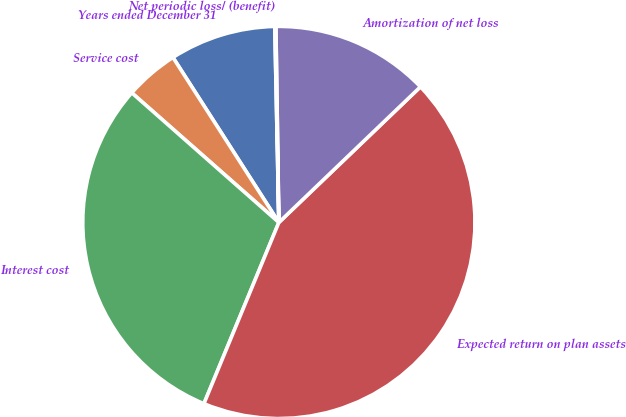<chart> <loc_0><loc_0><loc_500><loc_500><pie_chart><fcel>Years ended December 31<fcel>Service cost<fcel>Interest cost<fcel>Expected return on plan assets<fcel>Amortization of net loss<fcel>Net periodic loss/ (benefit)<nl><fcel>8.75%<fcel>4.42%<fcel>30.26%<fcel>43.4%<fcel>13.08%<fcel>0.09%<nl></chart> 